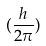<formula> <loc_0><loc_0><loc_500><loc_500>( \frac { h } { 2 \pi } )</formula> 